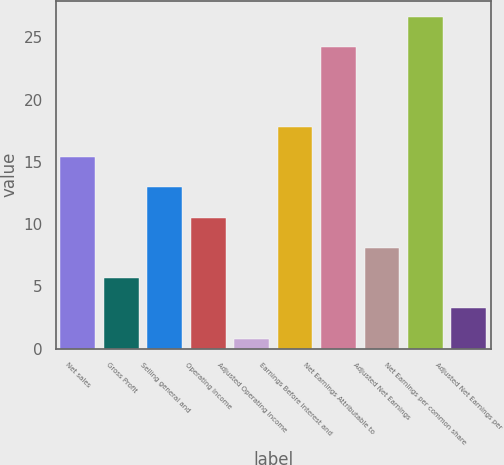<chart> <loc_0><loc_0><loc_500><loc_500><bar_chart><fcel>Net sales<fcel>Gross Profit<fcel>Selling general and<fcel>Operating Income<fcel>Adjusted Operating Income<fcel>Earnings Before Interest and<fcel>Net Earnings Attributable to<fcel>Adjusted Net Earnings<fcel>Net Earnings per common share<fcel>Adjusted Net Earnings per<nl><fcel>15.38<fcel>5.66<fcel>12.95<fcel>10.52<fcel>0.8<fcel>17.81<fcel>24.2<fcel>8.09<fcel>26.63<fcel>3.23<nl></chart> 